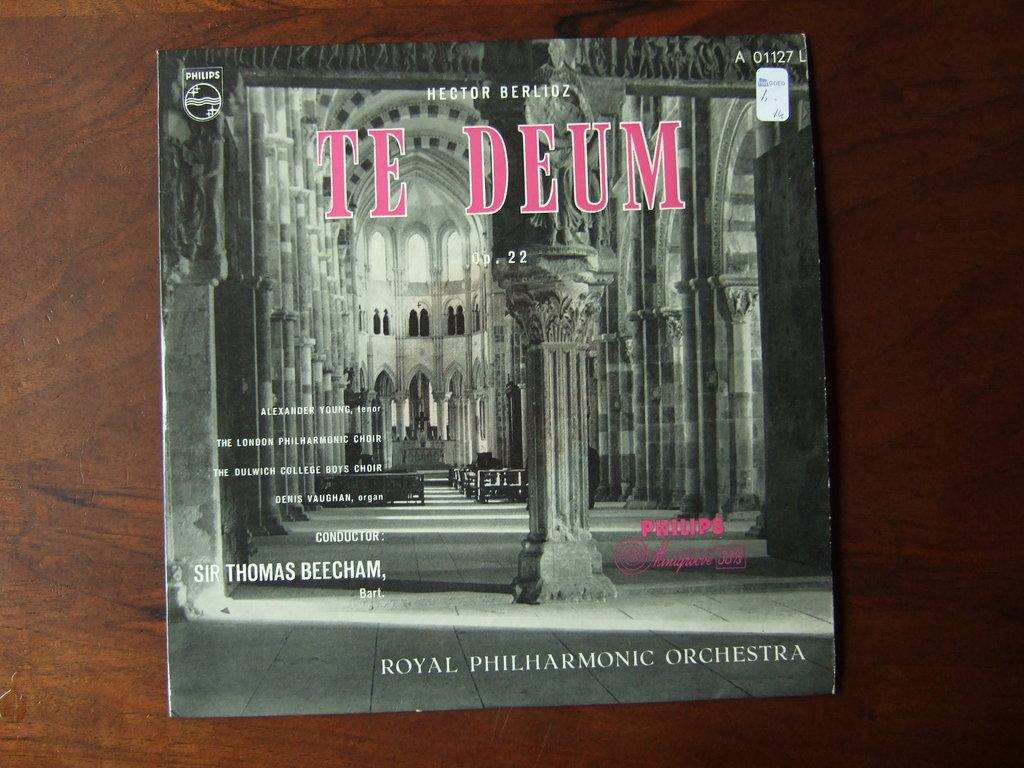<image>
Relay a brief, clear account of the picture shown. An album titled Te Deum in pink letters with conductor Sir Thomas Beecham. 